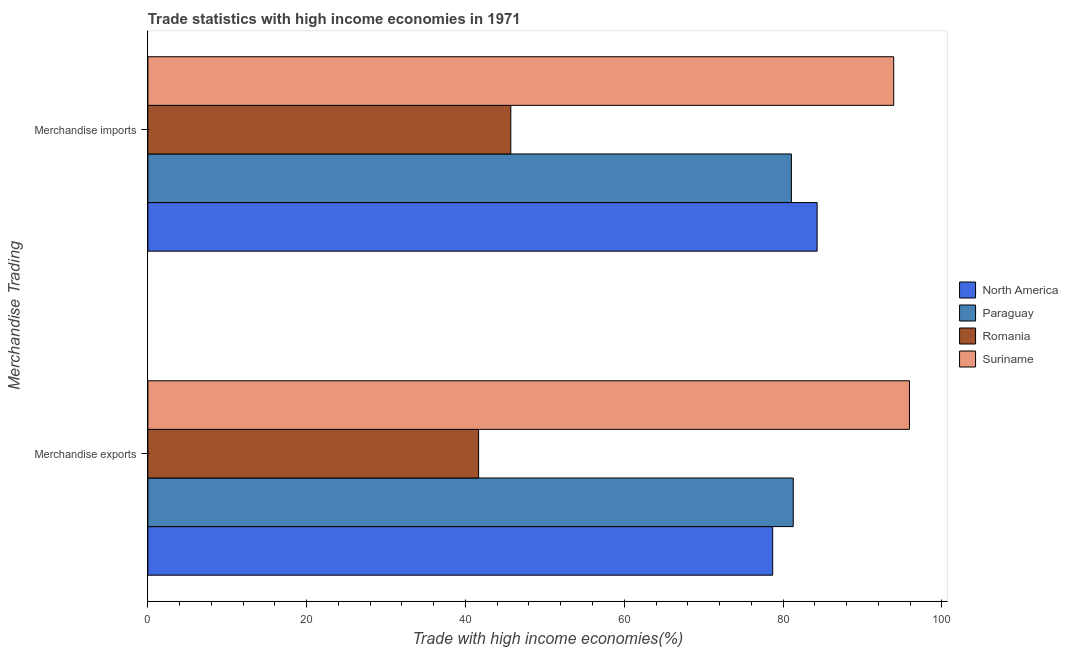How many different coloured bars are there?
Offer a very short reply. 4. How many groups of bars are there?
Your response must be concise. 2. Are the number of bars per tick equal to the number of legend labels?
Your answer should be very brief. Yes. What is the merchandise imports in Paraguay?
Keep it short and to the point. 81.06. Across all countries, what is the maximum merchandise exports?
Keep it short and to the point. 95.93. Across all countries, what is the minimum merchandise exports?
Offer a very short reply. 41.66. In which country was the merchandise exports maximum?
Give a very brief answer. Suriname. In which country was the merchandise exports minimum?
Provide a succinct answer. Romania. What is the total merchandise imports in the graph?
Your response must be concise. 305. What is the difference between the merchandise exports in Paraguay and that in North America?
Your answer should be very brief. 2.59. What is the difference between the merchandise imports in North America and the merchandise exports in Romania?
Your response must be concise. 42.64. What is the average merchandise imports per country?
Provide a short and direct response. 76.25. What is the difference between the merchandise imports and merchandise exports in Paraguay?
Provide a short and direct response. -0.23. In how many countries, is the merchandise imports greater than 48 %?
Make the answer very short. 3. What is the ratio of the merchandise imports in Romania to that in Paraguay?
Your response must be concise. 0.56. What does the 2nd bar from the top in Merchandise exports represents?
Ensure brevity in your answer.  Romania. What does the 2nd bar from the bottom in Merchandise imports represents?
Your answer should be very brief. Paraguay. What is the difference between two consecutive major ticks on the X-axis?
Your response must be concise. 20. Does the graph contain grids?
Offer a very short reply. No. What is the title of the graph?
Keep it short and to the point. Trade statistics with high income economies in 1971. Does "Turkmenistan" appear as one of the legend labels in the graph?
Provide a succinct answer. No. What is the label or title of the X-axis?
Provide a short and direct response. Trade with high income economies(%). What is the label or title of the Y-axis?
Your answer should be compact. Merchandise Trading. What is the Trade with high income economies(%) in North America in Merchandise exports?
Your answer should be compact. 78.7. What is the Trade with high income economies(%) in Paraguay in Merchandise exports?
Provide a succinct answer. 81.29. What is the Trade with high income economies(%) of Romania in Merchandise exports?
Your answer should be very brief. 41.66. What is the Trade with high income economies(%) in Suriname in Merchandise exports?
Your answer should be very brief. 95.93. What is the Trade with high income economies(%) of North America in Merchandise imports?
Offer a very short reply. 84.29. What is the Trade with high income economies(%) in Paraguay in Merchandise imports?
Make the answer very short. 81.06. What is the Trade with high income economies(%) of Romania in Merchandise imports?
Your answer should be very brief. 45.71. What is the Trade with high income economies(%) of Suriname in Merchandise imports?
Your answer should be compact. 93.94. Across all Merchandise Trading, what is the maximum Trade with high income economies(%) in North America?
Your answer should be very brief. 84.29. Across all Merchandise Trading, what is the maximum Trade with high income economies(%) of Paraguay?
Ensure brevity in your answer.  81.29. Across all Merchandise Trading, what is the maximum Trade with high income economies(%) in Romania?
Keep it short and to the point. 45.71. Across all Merchandise Trading, what is the maximum Trade with high income economies(%) in Suriname?
Provide a short and direct response. 95.93. Across all Merchandise Trading, what is the minimum Trade with high income economies(%) in North America?
Give a very brief answer. 78.7. Across all Merchandise Trading, what is the minimum Trade with high income economies(%) of Paraguay?
Your answer should be compact. 81.06. Across all Merchandise Trading, what is the minimum Trade with high income economies(%) in Romania?
Give a very brief answer. 41.66. Across all Merchandise Trading, what is the minimum Trade with high income economies(%) of Suriname?
Provide a succinct answer. 93.94. What is the total Trade with high income economies(%) of North America in the graph?
Your answer should be very brief. 162.99. What is the total Trade with high income economies(%) in Paraguay in the graph?
Provide a succinct answer. 162.34. What is the total Trade with high income economies(%) of Romania in the graph?
Keep it short and to the point. 87.37. What is the total Trade with high income economies(%) of Suriname in the graph?
Your response must be concise. 189.86. What is the difference between the Trade with high income economies(%) of North America in Merchandise exports and that in Merchandise imports?
Give a very brief answer. -5.6. What is the difference between the Trade with high income economies(%) of Paraguay in Merchandise exports and that in Merchandise imports?
Your answer should be very brief. 0.23. What is the difference between the Trade with high income economies(%) in Romania in Merchandise exports and that in Merchandise imports?
Make the answer very short. -4.06. What is the difference between the Trade with high income economies(%) in Suriname in Merchandise exports and that in Merchandise imports?
Your answer should be compact. 1.99. What is the difference between the Trade with high income economies(%) of North America in Merchandise exports and the Trade with high income economies(%) of Paraguay in Merchandise imports?
Make the answer very short. -2.36. What is the difference between the Trade with high income economies(%) in North America in Merchandise exports and the Trade with high income economies(%) in Romania in Merchandise imports?
Offer a terse response. 32.99. What is the difference between the Trade with high income economies(%) in North America in Merchandise exports and the Trade with high income economies(%) in Suriname in Merchandise imports?
Keep it short and to the point. -15.24. What is the difference between the Trade with high income economies(%) of Paraguay in Merchandise exports and the Trade with high income economies(%) of Romania in Merchandise imports?
Provide a succinct answer. 35.58. What is the difference between the Trade with high income economies(%) of Paraguay in Merchandise exports and the Trade with high income economies(%) of Suriname in Merchandise imports?
Give a very brief answer. -12.65. What is the difference between the Trade with high income economies(%) of Romania in Merchandise exports and the Trade with high income economies(%) of Suriname in Merchandise imports?
Give a very brief answer. -52.28. What is the average Trade with high income economies(%) in North America per Merchandise Trading?
Your response must be concise. 81.5. What is the average Trade with high income economies(%) of Paraguay per Merchandise Trading?
Keep it short and to the point. 81.17. What is the average Trade with high income economies(%) in Romania per Merchandise Trading?
Keep it short and to the point. 43.69. What is the average Trade with high income economies(%) in Suriname per Merchandise Trading?
Ensure brevity in your answer.  94.93. What is the difference between the Trade with high income economies(%) of North America and Trade with high income economies(%) of Paraguay in Merchandise exports?
Provide a short and direct response. -2.59. What is the difference between the Trade with high income economies(%) in North America and Trade with high income economies(%) in Romania in Merchandise exports?
Ensure brevity in your answer.  37.04. What is the difference between the Trade with high income economies(%) of North America and Trade with high income economies(%) of Suriname in Merchandise exports?
Provide a succinct answer. -17.23. What is the difference between the Trade with high income economies(%) of Paraguay and Trade with high income economies(%) of Romania in Merchandise exports?
Offer a very short reply. 39.63. What is the difference between the Trade with high income economies(%) in Paraguay and Trade with high income economies(%) in Suriname in Merchandise exports?
Provide a succinct answer. -14.64. What is the difference between the Trade with high income economies(%) of Romania and Trade with high income economies(%) of Suriname in Merchandise exports?
Ensure brevity in your answer.  -54.27. What is the difference between the Trade with high income economies(%) in North America and Trade with high income economies(%) in Paraguay in Merchandise imports?
Provide a short and direct response. 3.24. What is the difference between the Trade with high income economies(%) of North America and Trade with high income economies(%) of Romania in Merchandise imports?
Ensure brevity in your answer.  38.58. What is the difference between the Trade with high income economies(%) in North America and Trade with high income economies(%) in Suriname in Merchandise imports?
Make the answer very short. -9.64. What is the difference between the Trade with high income economies(%) of Paraguay and Trade with high income economies(%) of Romania in Merchandise imports?
Provide a succinct answer. 35.34. What is the difference between the Trade with high income economies(%) of Paraguay and Trade with high income economies(%) of Suriname in Merchandise imports?
Your answer should be very brief. -12.88. What is the difference between the Trade with high income economies(%) in Romania and Trade with high income economies(%) in Suriname in Merchandise imports?
Offer a terse response. -48.22. What is the ratio of the Trade with high income economies(%) of North America in Merchandise exports to that in Merchandise imports?
Offer a terse response. 0.93. What is the ratio of the Trade with high income economies(%) in Paraguay in Merchandise exports to that in Merchandise imports?
Give a very brief answer. 1. What is the ratio of the Trade with high income economies(%) of Romania in Merchandise exports to that in Merchandise imports?
Your answer should be compact. 0.91. What is the ratio of the Trade with high income economies(%) in Suriname in Merchandise exports to that in Merchandise imports?
Ensure brevity in your answer.  1.02. What is the difference between the highest and the second highest Trade with high income economies(%) of North America?
Offer a very short reply. 5.6. What is the difference between the highest and the second highest Trade with high income economies(%) in Paraguay?
Your answer should be compact. 0.23. What is the difference between the highest and the second highest Trade with high income economies(%) in Romania?
Provide a succinct answer. 4.06. What is the difference between the highest and the second highest Trade with high income economies(%) of Suriname?
Give a very brief answer. 1.99. What is the difference between the highest and the lowest Trade with high income economies(%) of North America?
Make the answer very short. 5.6. What is the difference between the highest and the lowest Trade with high income economies(%) of Paraguay?
Keep it short and to the point. 0.23. What is the difference between the highest and the lowest Trade with high income economies(%) of Romania?
Your answer should be very brief. 4.06. What is the difference between the highest and the lowest Trade with high income economies(%) of Suriname?
Make the answer very short. 1.99. 